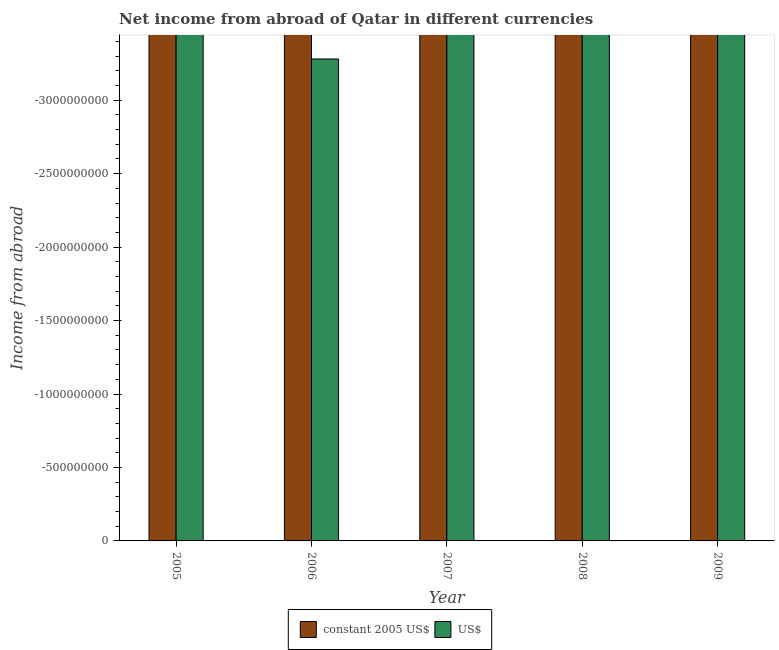Are the number of bars per tick equal to the number of legend labels?
Ensure brevity in your answer.  No. Are the number of bars on each tick of the X-axis equal?
Your answer should be very brief. Yes. How many bars are there on the 1st tick from the left?
Offer a very short reply. 0. What is the label of the 1st group of bars from the left?
Offer a very short reply. 2005. In how many cases, is the number of bars for a given year not equal to the number of legend labels?
Your answer should be compact. 5. What is the income from abroad in us$ in 2009?
Your answer should be compact. 0. In how many years, is the income from abroad in us$ greater than -2500000000 units?
Keep it short and to the point. 0. How many bars are there?
Your answer should be compact. 0. How many years are there in the graph?
Your answer should be very brief. 5. What is the difference between two consecutive major ticks on the Y-axis?
Provide a succinct answer. 5.00e+08. Does the graph contain any zero values?
Offer a very short reply. Yes. How many legend labels are there?
Your answer should be very brief. 2. How are the legend labels stacked?
Provide a short and direct response. Horizontal. What is the title of the graph?
Provide a succinct answer. Net income from abroad of Qatar in different currencies. Does "Highest 20% of population" appear as one of the legend labels in the graph?
Give a very brief answer. No. What is the label or title of the Y-axis?
Provide a succinct answer. Income from abroad. What is the Income from abroad of constant 2005 US$ in 2006?
Provide a short and direct response. 0. What is the Income from abroad in constant 2005 US$ in 2007?
Provide a succinct answer. 0. What is the Income from abroad of US$ in 2007?
Make the answer very short. 0. What is the Income from abroad in constant 2005 US$ in 2008?
Provide a succinct answer. 0. What is the total Income from abroad in constant 2005 US$ in the graph?
Offer a terse response. 0. What is the average Income from abroad in constant 2005 US$ per year?
Ensure brevity in your answer.  0. 